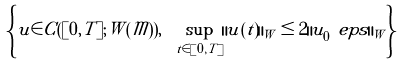Convert formula to latex. <formula><loc_0><loc_0><loc_500><loc_500>\left \{ u \in C ( [ 0 , T ] ; W ( \mathcal { M } ) ) , \ \sup _ { t \in [ 0 , T ] } \| u ( t ) \| _ { W } \leq 2 \| u _ { 0 } ^ { \ } e p s \| _ { W } \right \}</formula> 